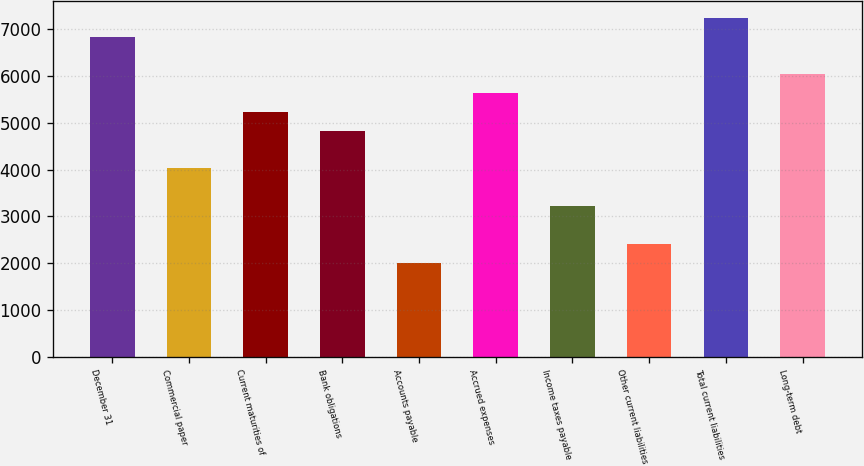Convert chart. <chart><loc_0><loc_0><loc_500><loc_500><bar_chart><fcel>December 31<fcel>Commercial paper<fcel>Current maturities of<fcel>Bank obligations<fcel>Accounts payable<fcel>Accrued expenses<fcel>Income taxes payable<fcel>Other current liabilities<fcel>Total current liabilities<fcel>Long-term debt<nl><fcel>6841.8<fcel>4025<fcel>5232.2<fcel>4829.8<fcel>2013<fcel>5634.6<fcel>3220.2<fcel>2415.4<fcel>7244.2<fcel>6037<nl></chart> 